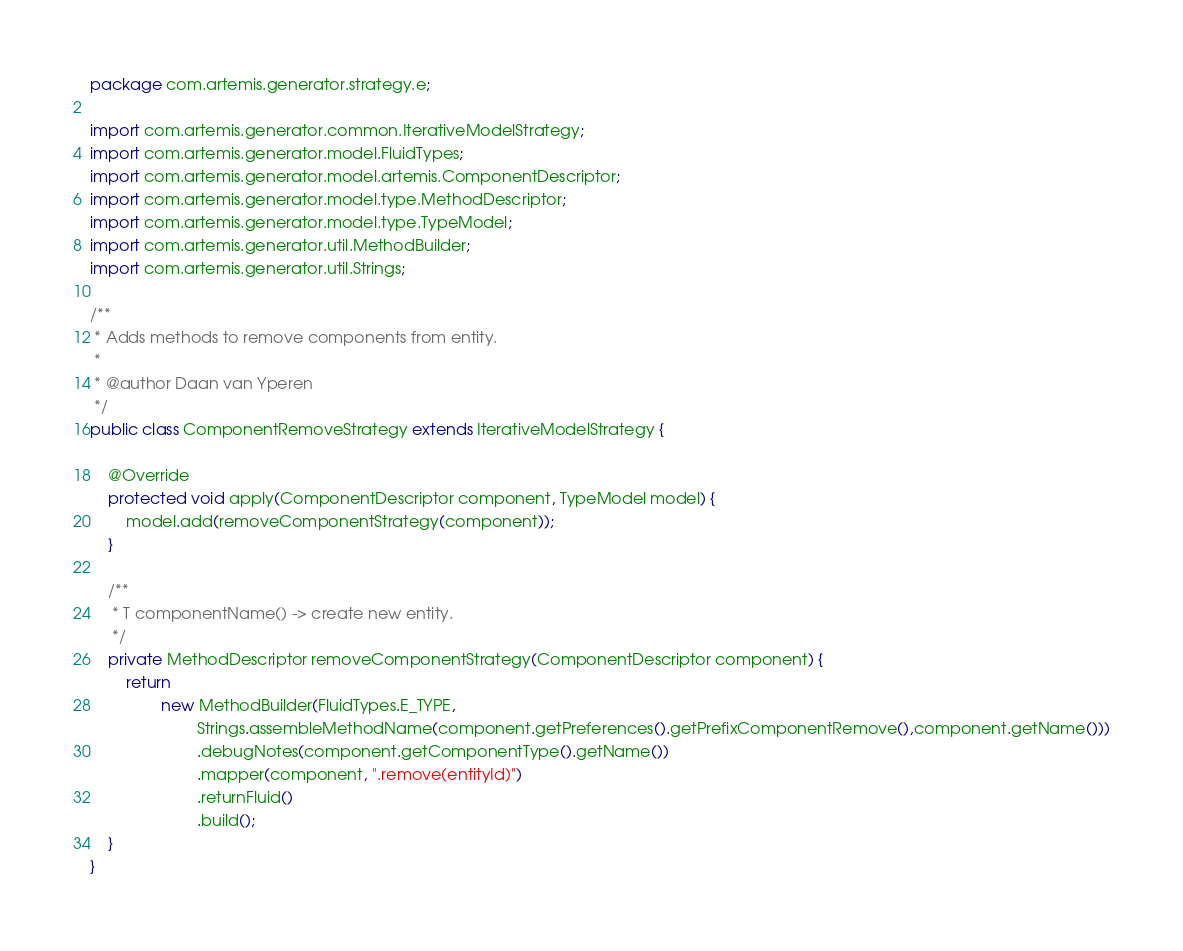<code> <loc_0><loc_0><loc_500><loc_500><_Java_>package com.artemis.generator.strategy.e;

import com.artemis.generator.common.IterativeModelStrategy;
import com.artemis.generator.model.FluidTypes;
import com.artemis.generator.model.artemis.ComponentDescriptor;
import com.artemis.generator.model.type.MethodDescriptor;
import com.artemis.generator.model.type.TypeModel;
import com.artemis.generator.util.MethodBuilder;
import com.artemis.generator.util.Strings;

/**
 * Adds methods to remove components from entity.
 *
 * @author Daan van Yperen
 */
public class ComponentRemoveStrategy extends IterativeModelStrategy {

    @Override
    protected void apply(ComponentDescriptor component, TypeModel model) {
        model.add(removeComponentStrategy(component));
    }

    /**
     * T componentName() -> create new entity.
     */
    private MethodDescriptor removeComponentStrategy(ComponentDescriptor component) {
        return
                new MethodBuilder(FluidTypes.E_TYPE,
                        Strings.assembleMethodName(component.getPreferences().getPrefixComponentRemove(),component.getName()))
                        .debugNotes(component.getComponentType().getName())
                        .mapper(component, ".remove(entityId)")
                        .returnFluid()
                        .build();
    }
}
</code> 